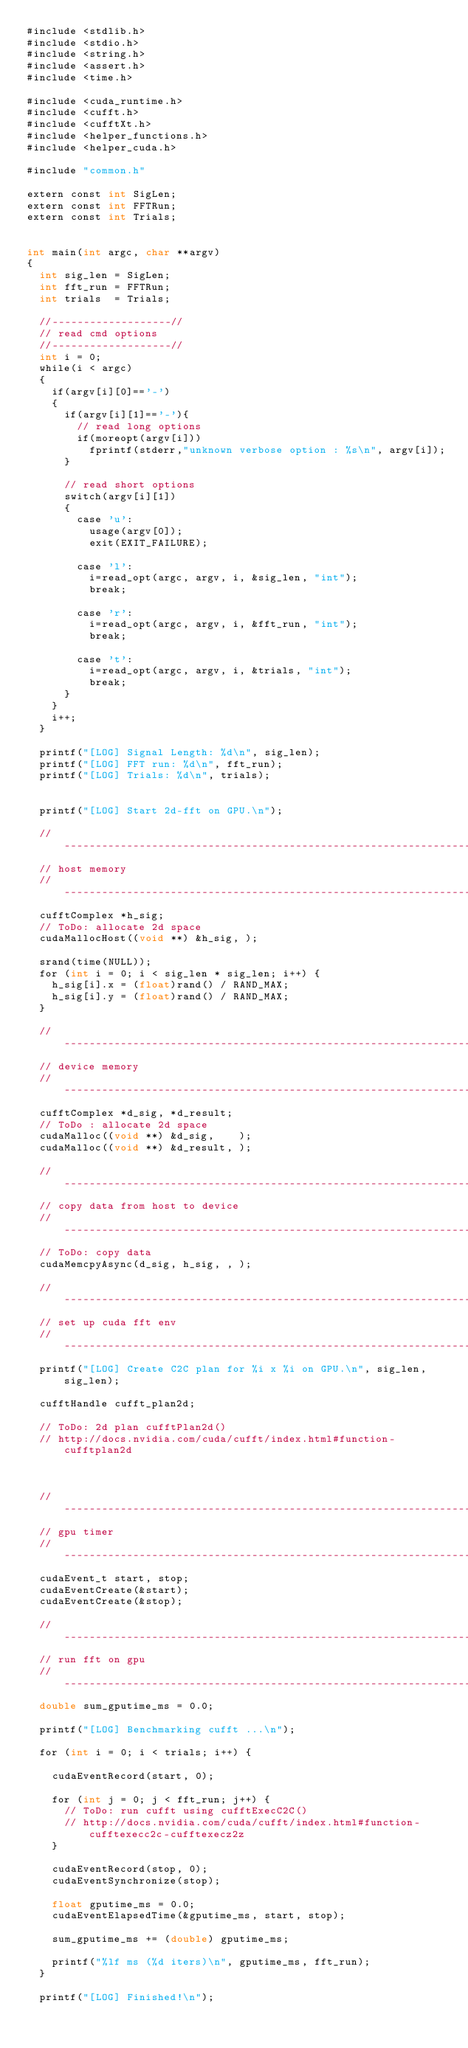Convert code to text. <code><loc_0><loc_0><loc_500><loc_500><_Cuda_>#include <stdlib.h>
#include <stdio.h>
#include <string.h>
#include <assert.h>
#include <time.h>

#include <cuda_runtime.h>
#include <cufft.h>
#include <cufftXt.h>
#include <helper_functions.h>
#include <helper_cuda.h>

#include "common.h"

extern const int SigLen;
extern const int FFTRun;
extern const int Trials; 


int main(int argc, char **argv)
{
	int sig_len = SigLen;
	int fft_run = FFTRun;
	int trials  = Trials;

	//-------------------//
	// read cmd options
	//-------------------//
	int i = 0;
	while(i < argc)
	{
		if(argv[i][0]=='-') 
		{
			if(argv[i][1]=='-'){
				// read long options
				if(moreopt(argv[i]))
					fprintf(stderr,"unknown verbose option : %s\n", argv[i]);
			}	

			// read short options
			switch(argv[i][1])
			{
				case 'u':
					usage(argv[0]);
					exit(EXIT_FAILURE);

				case 'l':
					i=read_opt(argc, argv, i, &sig_len, "int");
					break;

				case 'r':
					i=read_opt(argc, argv, i, &fft_run, "int");
					break;

				case 't':
					i=read_opt(argc, argv, i, &trials, "int");
					break;
			}
		}
		i++;
	}

	printf("[LOG] Signal Length: %d\n", sig_len);
	printf("[LOG] FFT run: %d\n", fft_run);
	printf("[LOG] Trials: %d\n", trials);


	printf("[LOG] Start 2d-fft on GPU.\n");

	//------------------------------------------------------------------------//
	// host memory
	//------------------------------------------------------------------------//
	cufftComplex *h_sig;
	// ToDo: allocate 2d space
	cudaMallocHost((void **) &h_sig, );

	srand(time(NULL));
	for (int i = 0; i < sig_len * sig_len; i++) {
		h_sig[i].x = (float)rand() / RAND_MAX;
		h_sig[i].y = (float)rand() / RAND_MAX;
	}

	//------------------------------------------------------------------------//
	// device memory
	//------------------------------------------------------------------------//
	cufftComplex *d_sig, *d_result;
	// ToDo : allocate 2d space
	cudaMalloc((void **) &d_sig,    );
	cudaMalloc((void **) &d_result, );

	//------------------------------------------------------------------------//
	// copy data from host to device 
	//------------------------------------------------------------------------//
	// ToDo: copy data
	cudaMemcpyAsync(d_sig, h_sig, , );

	//------------------------------------------------------------------------//
	// set up cuda fft env 
	//------------------------------------------------------------------------//
	printf("[LOG] Create C2C plan for %i x %i on GPU.\n", sig_len, sig_len);

	cufftHandle cufft_plan2d;

	// ToDo: 2d plan cufftPlan2d()
	// http://docs.nvidia.com/cuda/cufft/index.html#function-cufftplan2d



	//------------------------------------------------------------------------//
	// gpu timer 
	//------------------------------------------------------------------------//
	cudaEvent_t start, stop;
	cudaEventCreate(&start);
	cudaEventCreate(&stop);

	//------------------------------------------------------------------------//
	// run fft on gpu 
	//------------------------------------------------------------------------//
	double sum_gputime_ms = 0.0;

	printf("[LOG] Benchmarking cufft ...\n");

	for (int i = 0; i < trials; i++) {

		cudaEventRecord(start, 0);

		for (int j = 0; j < fft_run; j++) {
			// ToDo: run cufft using cufftExecC2C()
			// http://docs.nvidia.com/cuda/cufft/index.html#function-cufftexecc2c-cufftexecz2z
		}

		cudaEventRecord(stop, 0);
		cudaEventSynchronize(stop);

		float gputime_ms = 0.0;
		cudaEventElapsedTime(&gputime_ms, start, stop);

		sum_gputime_ms += (double) gputime_ms;

		printf("%lf ms (%d iters)\n", gputime_ms, fft_run);
	}

	printf("[LOG] Finished!\n");</code> 